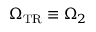<formula> <loc_0><loc_0><loc_500><loc_500>\Omega _ { T R } \equiv \Omega _ { 2 }</formula> 